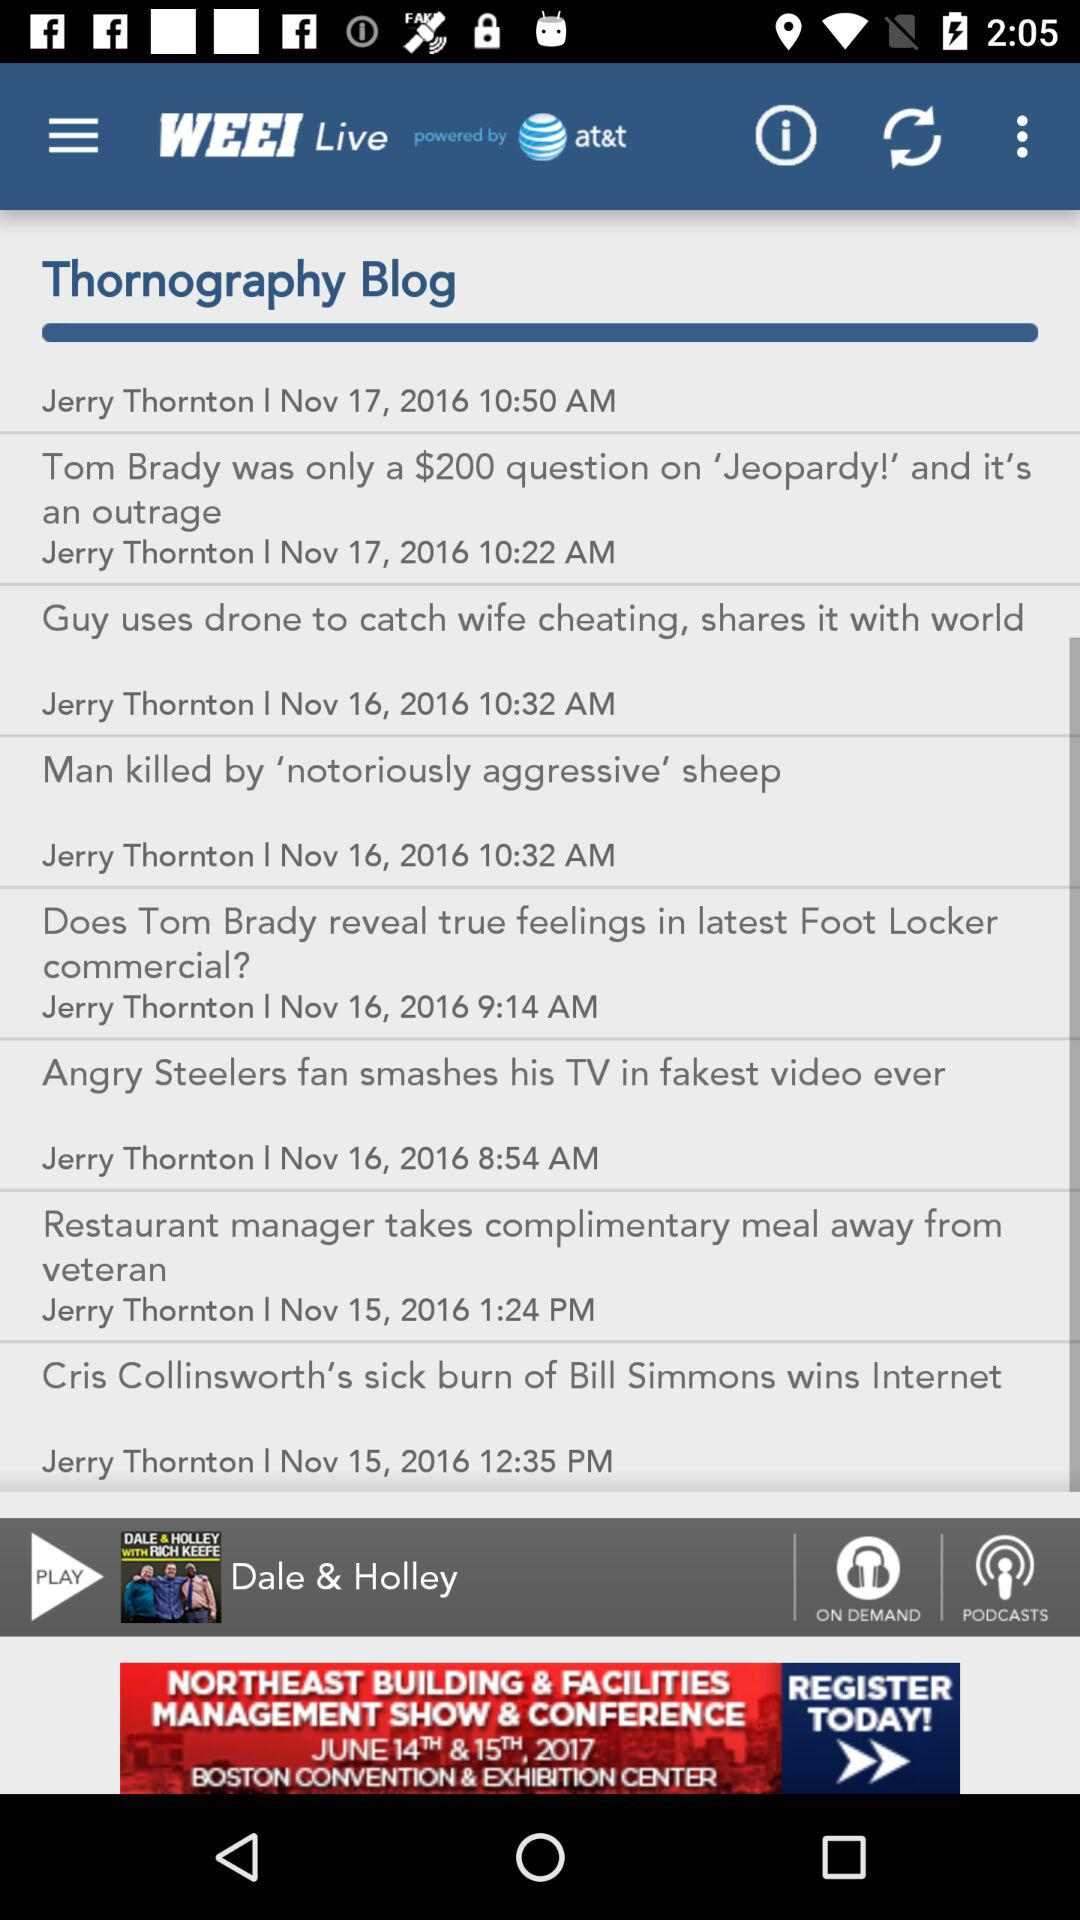What is the date of the blog "Man killed by 'notoriously aggressive' sheep"? The date is November 16, 2016. 